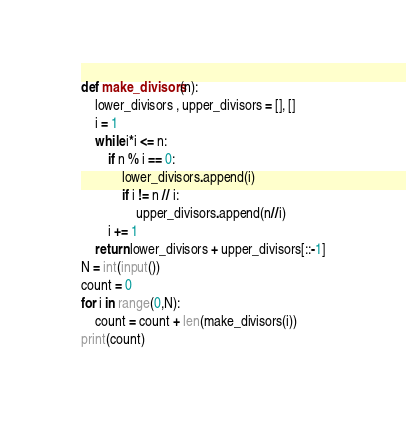Convert code to text. <code><loc_0><loc_0><loc_500><loc_500><_Python_>def make_divisors(n):
    lower_divisors , upper_divisors = [], []
    i = 1
    while i*i <= n:
        if n % i == 0:
            lower_divisors.append(i)
            if i != n // i:
                upper_divisors.append(n//i)
        i += 1
    return lower_divisors + upper_divisors[::-1]
N = int(input())
count = 0
for i in range(0,N):
    count = count + len(make_divisors(i))
print(count)</code> 